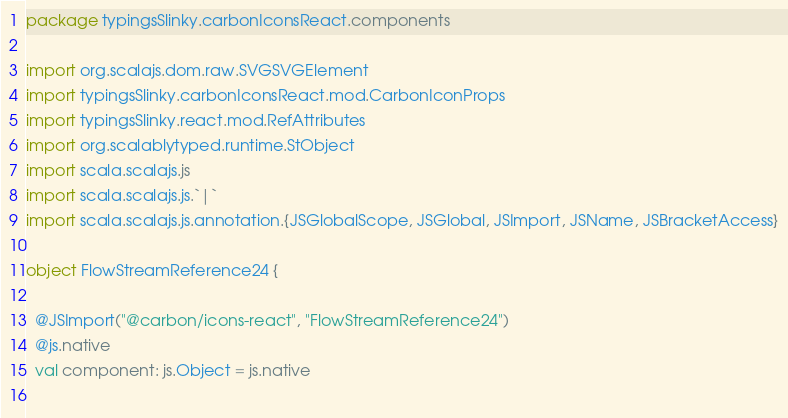<code> <loc_0><loc_0><loc_500><loc_500><_Scala_>package typingsSlinky.carbonIconsReact.components

import org.scalajs.dom.raw.SVGSVGElement
import typingsSlinky.carbonIconsReact.mod.CarbonIconProps
import typingsSlinky.react.mod.RefAttributes
import org.scalablytyped.runtime.StObject
import scala.scalajs.js
import scala.scalajs.js.`|`
import scala.scalajs.js.annotation.{JSGlobalScope, JSGlobal, JSImport, JSName, JSBracketAccess}

object FlowStreamReference24 {
  
  @JSImport("@carbon/icons-react", "FlowStreamReference24")
  @js.native
  val component: js.Object = js.native
  </code> 